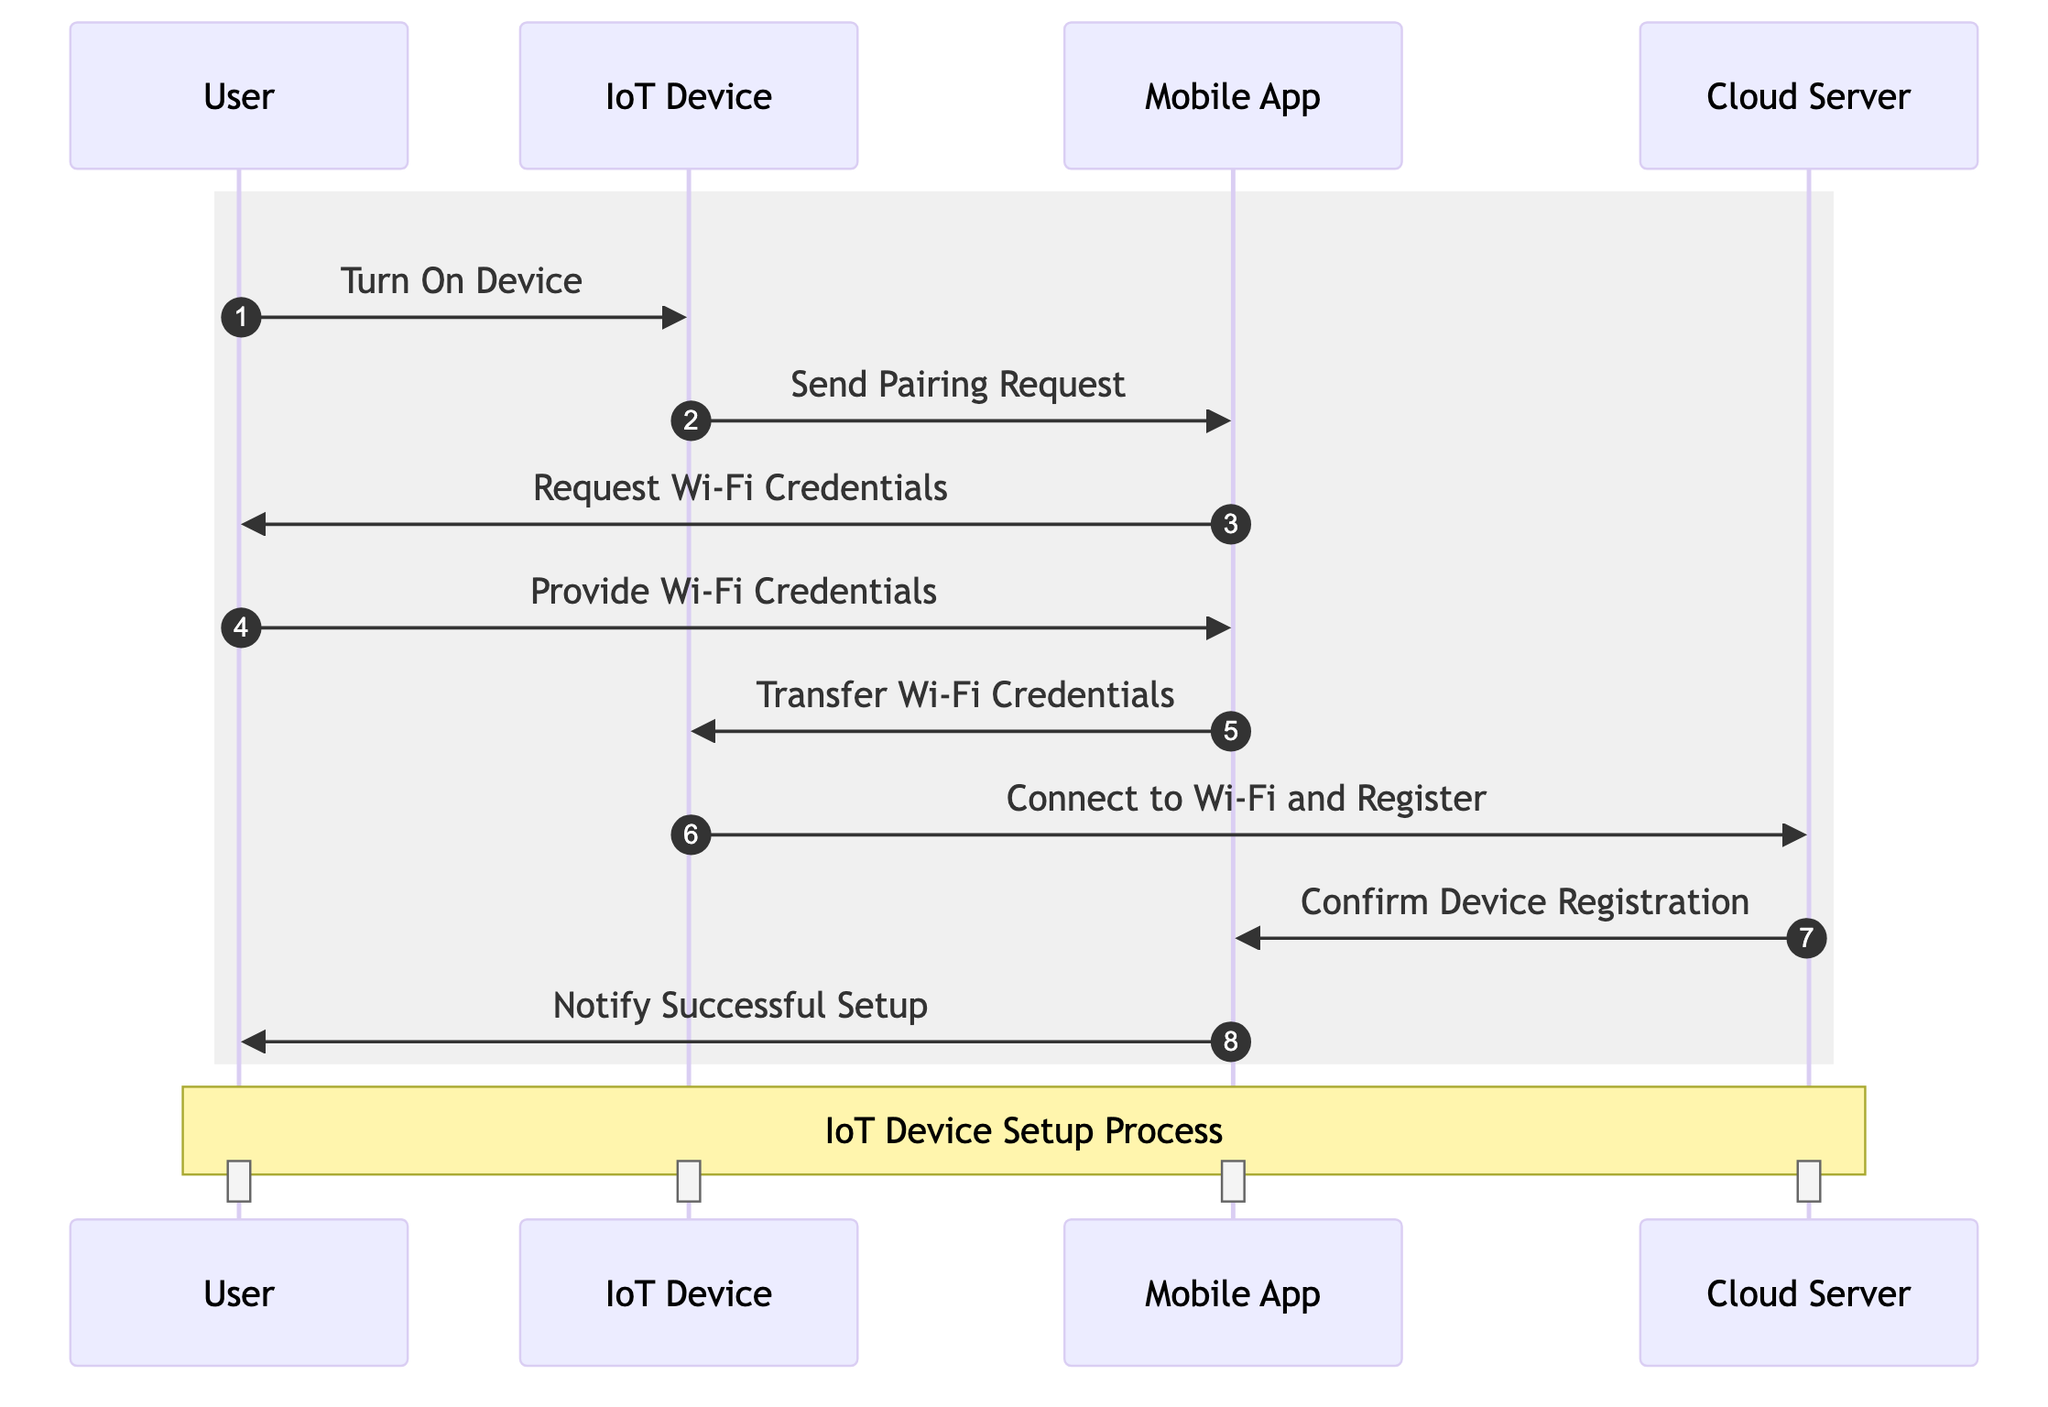What is the first action taken by the User? The first action listed in the sequence diagram is "Turn On Device," which is initiated by the User to start the device setup process.
Answer: Turn On Device How many messages are exchanged in total? By counting all messages in the sequence diagram from the User to the IoT Device, to the Mobile App, and to the Cloud Server, there are a total of eight messages exchanged, reflecting the various steps of the setup process.
Answer: Eight What does the IoT Device send after being turned on? After the User turns on the IoT Device, the immediate action taken by the IoT Device is to "Send Pairing Request" to the Mobile App, which is the next step in the setup process.
Answer: Send Pairing Request Which actor receives the Wi-Fi credentials from the User? The Mobile App receives the Wi-Fi credentials from the User, as indicated by the message "Provide Wi-Fi Credentials," which is sent from the User to the Mobile App.
Answer: Mobile App What action confirms the device registration? The action that confirms the device registration is "Confirm Device Registration," which comes from the Cloud Server after the IoT Device has connected to Wi-Fi and registered itself.
Answer: Confirm Device Registration Which actor eventually notifies the User of the successful setup? The actor that notifies the User of the successful setup is the Mobile App, as shown by the message "Notify Successful Setup" sent from the Mobile App to the User.
Answer: Mobile App What is the last message in the sequence? The last message in the sequence diagram is "Notify Successful Setup," which indicates the completion of the setup process and is sent to the User from the Mobile App.
Answer: Notify Successful Setup How does the IoT Device register itself? The IoT Device registers itself by executing the action "Connect to Wi-Fi and Register," which indicates the necessary communication with the Cloud Server after receiving Wi-Fi credentials.
Answer: Connect to Wi-Fi and Register 